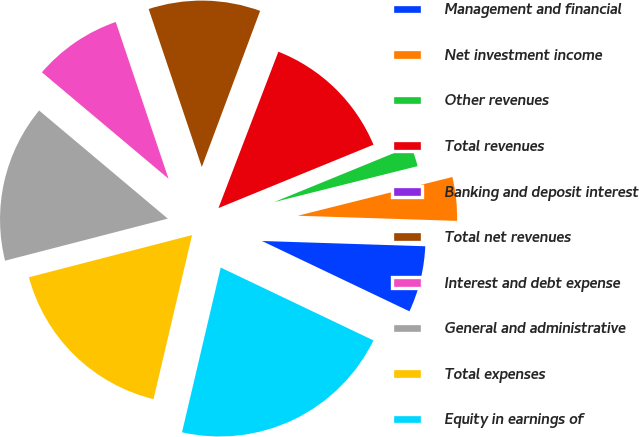Convert chart. <chart><loc_0><loc_0><loc_500><loc_500><pie_chart><fcel>Management and financial<fcel>Net investment income<fcel>Other revenues<fcel>Total revenues<fcel>Banking and deposit interest<fcel>Total net revenues<fcel>Interest and debt expense<fcel>General and administrative<fcel>Total expenses<fcel>Equity in earnings of<nl><fcel>6.57%<fcel>4.42%<fcel>2.27%<fcel>13.0%<fcel>0.13%<fcel>10.86%<fcel>8.71%<fcel>15.15%<fcel>17.3%<fcel>21.59%<nl></chart> 